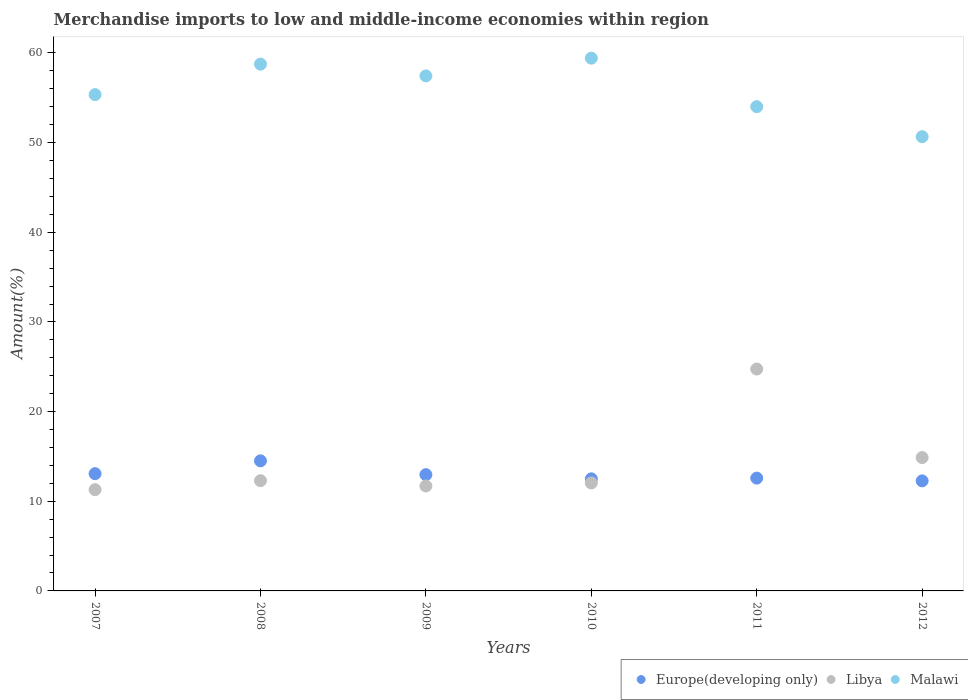How many different coloured dotlines are there?
Offer a terse response. 3. What is the percentage of amount earned from merchandise imports in Malawi in 2007?
Your answer should be very brief. 55.35. Across all years, what is the maximum percentage of amount earned from merchandise imports in Malawi?
Your answer should be very brief. 59.42. Across all years, what is the minimum percentage of amount earned from merchandise imports in Europe(developing only)?
Your response must be concise. 12.27. What is the total percentage of amount earned from merchandise imports in Europe(developing only) in the graph?
Offer a terse response. 77.91. What is the difference between the percentage of amount earned from merchandise imports in Europe(developing only) in 2008 and that in 2011?
Your answer should be compact. 1.93. What is the difference between the percentage of amount earned from merchandise imports in Malawi in 2011 and the percentage of amount earned from merchandise imports in Europe(developing only) in 2010?
Offer a very short reply. 41.51. What is the average percentage of amount earned from merchandise imports in Libya per year?
Your answer should be compact. 14.49. In the year 2008, what is the difference between the percentage of amount earned from merchandise imports in Malawi and percentage of amount earned from merchandise imports in Europe(developing only)?
Your answer should be very brief. 44.24. What is the ratio of the percentage of amount earned from merchandise imports in Malawi in 2007 to that in 2012?
Ensure brevity in your answer.  1.09. What is the difference between the highest and the second highest percentage of amount earned from merchandise imports in Malawi?
Keep it short and to the point. 0.67. What is the difference between the highest and the lowest percentage of amount earned from merchandise imports in Europe(developing only)?
Your answer should be very brief. 2.23. In how many years, is the percentage of amount earned from merchandise imports in Malawi greater than the average percentage of amount earned from merchandise imports in Malawi taken over all years?
Your response must be concise. 3. Is it the case that in every year, the sum of the percentage of amount earned from merchandise imports in Libya and percentage of amount earned from merchandise imports in Europe(developing only)  is greater than the percentage of amount earned from merchandise imports in Malawi?
Offer a terse response. No. Does the percentage of amount earned from merchandise imports in Libya monotonically increase over the years?
Give a very brief answer. No. How many dotlines are there?
Offer a very short reply. 3. Does the graph contain any zero values?
Offer a very short reply. No. How are the legend labels stacked?
Offer a terse response. Horizontal. What is the title of the graph?
Make the answer very short. Merchandise imports to low and middle-income economies within region. Does "Azerbaijan" appear as one of the legend labels in the graph?
Your answer should be very brief. No. What is the label or title of the Y-axis?
Your answer should be compact. Amount(%). What is the Amount(%) in Europe(developing only) in 2007?
Your answer should be very brief. 13.08. What is the Amount(%) of Libya in 2007?
Offer a very short reply. 11.29. What is the Amount(%) in Malawi in 2007?
Ensure brevity in your answer.  55.35. What is the Amount(%) of Europe(developing only) in 2008?
Your response must be concise. 14.51. What is the Amount(%) of Libya in 2008?
Keep it short and to the point. 12.29. What is the Amount(%) in Malawi in 2008?
Your answer should be compact. 58.75. What is the Amount(%) in Europe(developing only) in 2009?
Ensure brevity in your answer.  12.97. What is the Amount(%) of Libya in 2009?
Your response must be concise. 11.7. What is the Amount(%) in Malawi in 2009?
Ensure brevity in your answer.  57.44. What is the Amount(%) in Europe(developing only) in 2010?
Your answer should be compact. 12.5. What is the Amount(%) of Libya in 2010?
Offer a very short reply. 12.04. What is the Amount(%) of Malawi in 2010?
Provide a succinct answer. 59.42. What is the Amount(%) of Europe(developing only) in 2011?
Your response must be concise. 12.58. What is the Amount(%) in Libya in 2011?
Provide a short and direct response. 24.75. What is the Amount(%) of Malawi in 2011?
Offer a very short reply. 54.01. What is the Amount(%) in Europe(developing only) in 2012?
Your answer should be compact. 12.27. What is the Amount(%) of Libya in 2012?
Offer a terse response. 14.87. What is the Amount(%) of Malawi in 2012?
Ensure brevity in your answer.  50.66. Across all years, what is the maximum Amount(%) of Europe(developing only)?
Your answer should be very brief. 14.51. Across all years, what is the maximum Amount(%) in Libya?
Offer a terse response. 24.75. Across all years, what is the maximum Amount(%) in Malawi?
Give a very brief answer. 59.42. Across all years, what is the minimum Amount(%) in Europe(developing only)?
Your answer should be very brief. 12.27. Across all years, what is the minimum Amount(%) of Libya?
Provide a short and direct response. 11.29. Across all years, what is the minimum Amount(%) of Malawi?
Make the answer very short. 50.66. What is the total Amount(%) in Europe(developing only) in the graph?
Provide a succinct answer. 77.91. What is the total Amount(%) of Libya in the graph?
Offer a terse response. 86.95. What is the total Amount(%) of Malawi in the graph?
Offer a terse response. 335.63. What is the difference between the Amount(%) in Europe(developing only) in 2007 and that in 2008?
Provide a succinct answer. -1.43. What is the difference between the Amount(%) of Libya in 2007 and that in 2008?
Ensure brevity in your answer.  -1. What is the difference between the Amount(%) of Malawi in 2007 and that in 2008?
Your answer should be very brief. -3.4. What is the difference between the Amount(%) in Europe(developing only) in 2007 and that in 2009?
Provide a short and direct response. 0.11. What is the difference between the Amount(%) of Libya in 2007 and that in 2009?
Your answer should be very brief. -0.41. What is the difference between the Amount(%) of Malawi in 2007 and that in 2009?
Offer a terse response. -2.09. What is the difference between the Amount(%) of Europe(developing only) in 2007 and that in 2010?
Provide a succinct answer. 0.58. What is the difference between the Amount(%) in Libya in 2007 and that in 2010?
Offer a terse response. -0.75. What is the difference between the Amount(%) in Malawi in 2007 and that in 2010?
Make the answer very short. -4.07. What is the difference between the Amount(%) in Europe(developing only) in 2007 and that in 2011?
Make the answer very short. 0.5. What is the difference between the Amount(%) in Libya in 2007 and that in 2011?
Your response must be concise. -13.45. What is the difference between the Amount(%) in Malawi in 2007 and that in 2011?
Make the answer very short. 1.34. What is the difference between the Amount(%) of Europe(developing only) in 2007 and that in 2012?
Make the answer very short. 0.8. What is the difference between the Amount(%) in Libya in 2007 and that in 2012?
Ensure brevity in your answer.  -3.58. What is the difference between the Amount(%) in Malawi in 2007 and that in 2012?
Your response must be concise. 4.69. What is the difference between the Amount(%) in Europe(developing only) in 2008 and that in 2009?
Make the answer very short. 1.54. What is the difference between the Amount(%) in Libya in 2008 and that in 2009?
Offer a very short reply. 0.59. What is the difference between the Amount(%) of Malawi in 2008 and that in 2009?
Your response must be concise. 1.31. What is the difference between the Amount(%) of Europe(developing only) in 2008 and that in 2010?
Provide a short and direct response. 2.01. What is the difference between the Amount(%) in Libya in 2008 and that in 2010?
Your answer should be very brief. 0.25. What is the difference between the Amount(%) of Malawi in 2008 and that in 2010?
Keep it short and to the point. -0.67. What is the difference between the Amount(%) of Europe(developing only) in 2008 and that in 2011?
Give a very brief answer. 1.93. What is the difference between the Amount(%) of Libya in 2008 and that in 2011?
Your answer should be very brief. -12.45. What is the difference between the Amount(%) in Malawi in 2008 and that in 2011?
Ensure brevity in your answer.  4.74. What is the difference between the Amount(%) in Europe(developing only) in 2008 and that in 2012?
Make the answer very short. 2.23. What is the difference between the Amount(%) in Libya in 2008 and that in 2012?
Your answer should be very brief. -2.58. What is the difference between the Amount(%) in Malawi in 2008 and that in 2012?
Your answer should be compact. 8.09. What is the difference between the Amount(%) in Europe(developing only) in 2009 and that in 2010?
Make the answer very short. 0.47. What is the difference between the Amount(%) in Libya in 2009 and that in 2010?
Give a very brief answer. -0.34. What is the difference between the Amount(%) in Malawi in 2009 and that in 2010?
Provide a succinct answer. -1.98. What is the difference between the Amount(%) in Europe(developing only) in 2009 and that in 2011?
Make the answer very short. 0.39. What is the difference between the Amount(%) of Libya in 2009 and that in 2011?
Your answer should be very brief. -13.04. What is the difference between the Amount(%) in Malawi in 2009 and that in 2011?
Make the answer very short. 3.43. What is the difference between the Amount(%) in Europe(developing only) in 2009 and that in 2012?
Your answer should be very brief. 0.69. What is the difference between the Amount(%) in Libya in 2009 and that in 2012?
Provide a short and direct response. -3.17. What is the difference between the Amount(%) of Malawi in 2009 and that in 2012?
Your answer should be very brief. 6.78. What is the difference between the Amount(%) in Europe(developing only) in 2010 and that in 2011?
Provide a succinct answer. -0.08. What is the difference between the Amount(%) of Libya in 2010 and that in 2011?
Give a very brief answer. -12.71. What is the difference between the Amount(%) of Malawi in 2010 and that in 2011?
Make the answer very short. 5.41. What is the difference between the Amount(%) of Europe(developing only) in 2010 and that in 2012?
Give a very brief answer. 0.23. What is the difference between the Amount(%) of Libya in 2010 and that in 2012?
Ensure brevity in your answer.  -2.83. What is the difference between the Amount(%) of Malawi in 2010 and that in 2012?
Offer a terse response. 8.76. What is the difference between the Amount(%) of Europe(developing only) in 2011 and that in 2012?
Make the answer very short. 0.31. What is the difference between the Amount(%) of Libya in 2011 and that in 2012?
Ensure brevity in your answer.  9.87. What is the difference between the Amount(%) in Malawi in 2011 and that in 2012?
Keep it short and to the point. 3.35. What is the difference between the Amount(%) of Europe(developing only) in 2007 and the Amount(%) of Libya in 2008?
Your answer should be compact. 0.78. What is the difference between the Amount(%) of Europe(developing only) in 2007 and the Amount(%) of Malawi in 2008?
Offer a very short reply. -45.67. What is the difference between the Amount(%) of Libya in 2007 and the Amount(%) of Malawi in 2008?
Your answer should be compact. -47.46. What is the difference between the Amount(%) in Europe(developing only) in 2007 and the Amount(%) in Libya in 2009?
Offer a very short reply. 1.37. What is the difference between the Amount(%) of Europe(developing only) in 2007 and the Amount(%) of Malawi in 2009?
Give a very brief answer. -44.36. What is the difference between the Amount(%) in Libya in 2007 and the Amount(%) in Malawi in 2009?
Your answer should be compact. -46.14. What is the difference between the Amount(%) in Europe(developing only) in 2007 and the Amount(%) in Malawi in 2010?
Make the answer very short. -46.34. What is the difference between the Amount(%) of Libya in 2007 and the Amount(%) of Malawi in 2010?
Ensure brevity in your answer.  -48.13. What is the difference between the Amount(%) in Europe(developing only) in 2007 and the Amount(%) in Libya in 2011?
Ensure brevity in your answer.  -11.67. What is the difference between the Amount(%) in Europe(developing only) in 2007 and the Amount(%) in Malawi in 2011?
Your answer should be compact. -40.93. What is the difference between the Amount(%) in Libya in 2007 and the Amount(%) in Malawi in 2011?
Make the answer very short. -42.71. What is the difference between the Amount(%) of Europe(developing only) in 2007 and the Amount(%) of Libya in 2012?
Ensure brevity in your answer.  -1.8. What is the difference between the Amount(%) in Europe(developing only) in 2007 and the Amount(%) in Malawi in 2012?
Provide a short and direct response. -37.58. What is the difference between the Amount(%) of Libya in 2007 and the Amount(%) of Malawi in 2012?
Provide a short and direct response. -39.37. What is the difference between the Amount(%) of Europe(developing only) in 2008 and the Amount(%) of Libya in 2009?
Offer a very short reply. 2.8. What is the difference between the Amount(%) of Europe(developing only) in 2008 and the Amount(%) of Malawi in 2009?
Ensure brevity in your answer.  -42.93. What is the difference between the Amount(%) in Libya in 2008 and the Amount(%) in Malawi in 2009?
Offer a very short reply. -45.14. What is the difference between the Amount(%) of Europe(developing only) in 2008 and the Amount(%) of Libya in 2010?
Keep it short and to the point. 2.47. What is the difference between the Amount(%) in Europe(developing only) in 2008 and the Amount(%) in Malawi in 2010?
Your answer should be very brief. -44.91. What is the difference between the Amount(%) in Libya in 2008 and the Amount(%) in Malawi in 2010?
Ensure brevity in your answer.  -47.13. What is the difference between the Amount(%) of Europe(developing only) in 2008 and the Amount(%) of Libya in 2011?
Ensure brevity in your answer.  -10.24. What is the difference between the Amount(%) in Europe(developing only) in 2008 and the Amount(%) in Malawi in 2011?
Your answer should be compact. -39.5. What is the difference between the Amount(%) in Libya in 2008 and the Amount(%) in Malawi in 2011?
Ensure brevity in your answer.  -41.71. What is the difference between the Amount(%) of Europe(developing only) in 2008 and the Amount(%) of Libya in 2012?
Your answer should be compact. -0.37. What is the difference between the Amount(%) of Europe(developing only) in 2008 and the Amount(%) of Malawi in 2012?
Give a very brief answer. -36.16. What is the difference between the Amount(%) in Libya in 2008 and the Amount(%) in Malawi in 2012?
Your answer should be very brief. -38.37. What is the difference between the Amount(%) in Europe(developing only) in 2009 and the Amount(%) in Malawi in 2010?
Provide a short and direct response. -46.45. What is the difference between the Amount(%) of Libya in 2009 and the Amount(%) of Malawi in 2010?
Make the answer very short. -47.72. What is the difference between the Amount(%) in Europe(developing only) in 2009 and the Amount(%) in Libya in 2011?
Keep it short and to the point. -11.78. What is the difference between the Amount(%) of Europe(developing only) in 2009 and the Amount(%) of Malawi in 2011?
Your response must be concise. -41.04. What is the difference between the Amount(%) of Libya in 2009 and the Amount(%) of Malawi in 2011?
Your answer should be compact. -42.3. What is the difference between the Amount(%) of Europe(developing only) in 2009 and the Amount(%) of Libya in 2012?
Offer a terse response. -1.91. What is the difference between the Amount(%) of Europe(developing only) in 2009 and the Amount(%) of Malawi in 2012?
Provide a short and direct response. -37.69. What is the difference between the Amount(%) of Libya in 2009 and the Amount(%) of Malawi in 2012?
Offer a terse response. -38.96. What is the difference between the Amount(%) in Europe(developing only) in 2010 and the Amount(%) in Libya in 2011?
Your answer should be compact. -12.24. What is the difference between the Amount(%) in Europe(developing only) in 2010 and the Amount(%) in Malawi in 2011?
Keep it short and to the point. -41.51. What is the difference between the Amount(%) of Libya in 2010 and the Amount(%) of Malawi in 2011?
Your answer should be compact. -41.97. What is the difference between the Amount(%) in Europe(developing only) in 2010 and the Amount(%) in Libya in 2012?
Offer a very short reply. -2.37. What is the difference between the Amount(%) of Europe(developing only) in 2010 and the Amount(%) of Malawi in 2012?
Give a very brief answer. -38.16. What is the difference between the Amount(%) of Libya in 2010 and the Amount(%) of Malawi in 2012?
Your answer should be compact. -38.62. What is the difference between the Amount(%) of Europe(developing only) in 2011 and the Amount(%) of Libya in 2012?
Your response must be concise. -2.29. What is the difference between the Amount(%) in Europe(developing only) in 2011 and the Amount(%) in Malawi in 2012?
Offer a very short reply. -38.08. What is the difference between the Amount(%) in Libya in 2011 and the Amount(%) in Malawi in 2012?
Keep it short and to the point. -25.92. What is the average Amount(%) of Europe(developing only) per year?
Your response must be concise. 12.99. What is the average Amount(%) of Libya per year?
Ensure brevity in your answer.  14.49. What is the average Amount(%) of Malawi per year?
Keep it short and to the point. 55.94. In the year 2007, what is the difference between the Amount(%) of Europe(developing only) and Amount(%) of Libya?
Your answer should be very brief. 1.78. In the year 2007, what is the difference between the Amount(%) of Europe(developing only) and Amount(%) of Malawi?
Your answer should be very brief. -42.27. In the year 2007, what is the difference between the Amount(%) of Libya and Amount(%) of Malawi?
Provide a short and direct response. -44.06. In the year 2008, what is the difference between the Amount(%) in Europe(developing only) and Amount(%) in Libya?
Your answer should be very brief. 2.21. In the year 2008, what is the difference between the Amount(%) of Europe(developing only) and Amount(%) of Malawi?
Your answer should be very brief. -44.24. In the year 2008, what is the difference between the Amount(%) in Libya and Amount(%) in Malawi?
Provide a succinct answer. -46.46. In the year 2009, what is the difference between the Amount(%) of Europe(developing only) and Amount(%) of Libya?
Your answer should be very brief. 1.26. In the year 2009, what is the difference between the Amount(%) of Europe(developing only) and Amount(%) of Malawi?
Offer a terse response. -44.47. In the year 2009, what is the difference between the Amount(%) of Libya and Amount(%) of Malawi?
Provide a short and direct response. -45.73. In the year 2010, what is the difference between the Amount(%) in Europe(developing only) and Amount(%) in Libya?
Provide a short and direct response. 0.46. In the year 2010, what is the difference between the Amount(%) in Europe(developing only) and Amount(%) in Malawi?
Your response must be concise. -46.92. In the year 2010, what is the difference between the Amount(%) of Libya and Amount(%) of Malawi?
Provide a succinct answer. -47.38. In the year 2011, what is the difference between the Amount(%) in Europe(developing only) and Amount(%) in Libya?
Ensure brevity in your answer.  -12.16. In the year 2011, what is the difference between the Amount(%) in Europe(developing only) and Amount(%) in Malawi?
Offer a very short reply. -41.43. In the year 2011, what is the difference between the Amount(%) in Libya and Amount(%) in Malawi?
Provide a short and direct response. -29.26. In the year 2012, what is the difference between the Amount(%) in Europe(developing only) and Amount(%) in Libya?
Your response must be concise. -2.6. In the year 2012, what is the difference between the Amount(%) of Europe(developing only) and Amount(%) of Malawi?
Offer a very short reply. -38.39. In the year 2012, what is the difference between the Amount(%) in Libya and Amount(%) in Malawi?
Keep it short and to the point. -35.79. What is the ratio of the Amount(%) in Europe(developing only) in 2007 to that in 2008?
Provide a succinct answer. 0.9. What is the ratio of the Amount(%) of Libya in 2007 to that in 2008?
Your answer should be compact. 0.92. What is the ratio of the Amount(%) in Malawi in 2007 to that in 2008?
Give a very brief answer. 0.94. What is the ratio of the Amount(%) in Europe(developing only) in 2007 to that in 2009?
Offer a terse response. 1.01. What is the ratio of the Amount(%) in Libya in 2007 to that in 2009?
Make the answer very short. 0.96. What is the ratio of the Amount(%) in Malawi in 2007 to that in 2009?
Your response must be concise. 0.96. What is the ratio of the Amount(%) in Europe(developing only) in 2007 to that in 2010?
Provide a short and direct response. 1.05. What is the ratio of the Amount(%) in Libya in 2007 to that in 2010?
Your answer should be compact. 0.94. What is the ratio of the Amount(%) in Malawi in 2007 to that in 2010?
Keep it short and to the point. 0.93. What is the ratio of the Amount(%) in Europe(developing only) in 2007 to that in 2011?
Ensure brevity in your answer.  1.04. What is the ratio of the Amount(%) of Libya in 2007 to that in 2011?
Your response must be concise. 0.46. What is the ratio of the Amount(%) of Malawi in 2007 to that in 2011?
Provide a succinct answer. 1.02. What is the ratio of the Amount(%) of Europe(developing only) in 2007 to that in 2012?
Ensure brevity in your answer.  1.07. What is the ratio of the Amount(%) in Libya in 2007 to that in 2012?
Give a very brief answer. 0.76. What is the ratio of the Amount(%) in Malawi in 2007 to that in 2012?
Ensure brevity in your answer.  1.09. What is the ratio of the Amount(%) of Europe(developing only) in 2008 to that in 2009?
Offer a terse response. 1.12. What is the ratio of the Amount(%) of Libya in 2008 to that in 2009?
Ensure brevity in your answer.  1.05. What is the ratio of the Amount(%) in Malawi in 2008 to that in 2009?
Ensure brevity in your answer.  1.02. What is the ratio of the Amount(%) in Europe(developing only) in 2008 to that in 2010?
Provide a succinct answer. 1.16. What is the ratio of the Amount(%) of Libya in 2008 to that in 2010?
Provide a short and direct response. 1.02. What is the ratio of the Amount(%) in Malawi in 2008 to that in 2010?
Provide a succinct answer. 0.99. What is the ratio of the Amount(%) of Europe(developing only) in 2008 to that in 2011?
Provide a short and direct response. 1.15. What is the ratio of the Amount(%) in Libya in 2008 to that in 2011?
Make the answer very short. 0.5. What is the ratio of the Amount(%) in Malawi in 2008 to that in 2011?
Provide a succinct answer. 1.09. What is the ratio of the Amount(%) in Europe(developing only) in 2008 to that in 2012?
Your answer should be very brief. 1.18. What is the ratio of the Amount(%) in Libya in 2008 to that in 2012?
Offer a very short reply. 0.83. What is the ratio of the Amount(%) in Malawi in 2008 to that in 2012?
Give a very brief answer. 1.16. What is the ratio of the Amount(%) of Europe(developing only) in 2009 to that in 2010?
Ensure brevity in your answer.  1.04. What is the ratio of the Amount(%) of Libya in 2009 to that in 2010?
Ensure brevity in your answer.  0.97. What is the ratio of the Amount(%) of Malawi in 2009 to that in 2010?
Give a very brief answer. 0.97. What is the ratio of the Amount(%) in Europe(developing only) in 2009 to that in 2011?
Ensure brevity in your answer.  1.03. What is the ratio of the Amount(%) in Libya in 2009 to that in 2011?
Make the answer very short. 0.47. What is the ratio of the Amount(%) of Malawi in 2009 to that in 2011?
Give a very brief answer. 1.06. What is the ratio of the Amount(%) of Europe(developing only) in 2009 to that in 2012?
Offer a very short reply. 1.06. What is the ratio of the Amount(%) of Libya in 2009 to that in 2012?
Your response must be concise. 0.79. What is the ratio of the Amount(%) in Malawi in 2009 to that in 2012?
Make the answer very short. 1.13. What is the ratio of the Amount(%) of Libya in 2010 to that in 2011?
Your answer should be compact. 0.49. What is the ratio of the Amount(%) in Malawi in 2010 to that in 2011?
Make the answer very short. 1.1. What is the ratio of the Amount(%) of Europe(developing only) in 2010 to that in 2012?
Keep it short and to the point. 1.02. What is the ratio of the Amount(%) in Libya in 2010 to that in 2012?
Provide a short and direct response. 0.81. What is the ratio of the Amount(%) of Malawi in 2010 to that in 2012?
Offer a very short reply. 1.17. What is the ratio of the Amount(%) in Europe(developing only) in 2011 to that in 2012?
Offer a terse response. 1.02. What is the ratio of the Amount(%) in Libya in 2011 to that in 2012?
Your answer should be very brief. 1.66. What is the ratio of the Amount(%) of Malawi in 2011 to that in 2012?
Your answer should be compact. 1.07. What is the difference between the highest and the second highest Amount(%) in Europe(developing only)?
Offer a very short reply. 1.43. What is the difference between the highest and the second highest Amount(%) of Libya?
Make the answer very short. 9.87. What is the difference between the highest and the second highest Amount(%) of Malawi?
Provide a succinct answer. 0.67. What is the difference between the highest and the lowest Amount(%) of Europe(developing only)?
Keep it short and to the point. 2.23. What is the difference between the highest and the lowest Amount(%) in Libya?
Provide a short and direct response. 13.45. What is the difference between the highest and the lowest Amount(%) in Malawi?
Your answer should be compact. 8.76. 